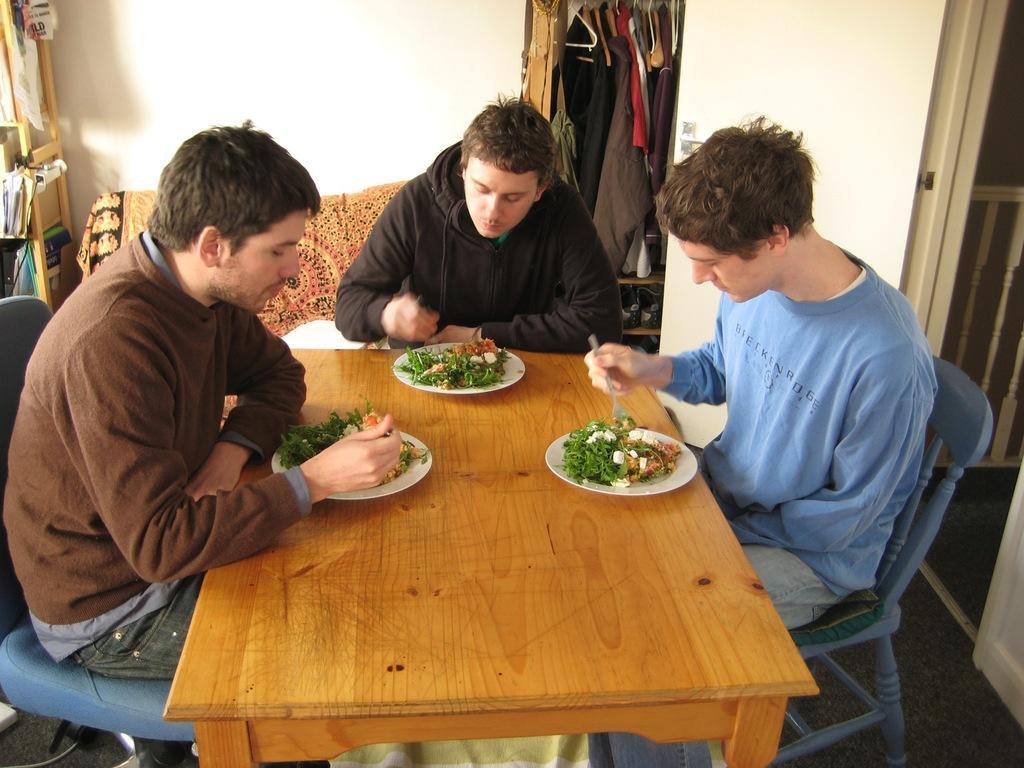How would you summarize this image in a sentence or two? This picture shows three men seated on the chairs and we see three plates and food in it on the table 